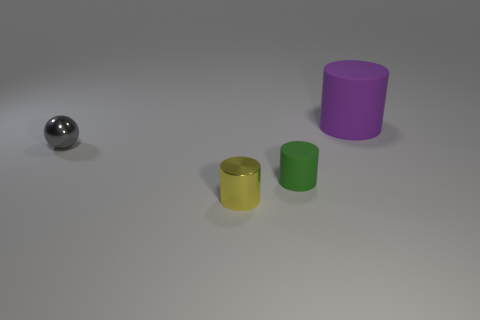Is there any other thing that is the same size as the purple rubber cylinder?
Make the answer very short. No. Do the cylinder behind the sphere and the tiny cylinder that is to the left of the green rubber object have the same material?
Give a very brief answer. No. What number of small yellow cylinders are in front of the tiny green cylinder?
Provide a short and direct response. 1. What number of purple things are tiny shiny things or tiny matte objects?
Provide a short and direct response. 0. There is a cylinder that is the same size as the yellow metallic thing; what is its material?
Offer a terse response. Rubber. What is the shape of the small thing that is both on the right side of the small shiny ball and behind the yellow shiny cylinder?
Ensure brevity in your answer.  Cylinder. There is a shiny ball that is the same size as the yellow shiny cylinder; what color is it?
Make the answer very short. Gray. Do the rubber object in front of the tiny gray sphere and the thing that is on the left side of the yellow shiny thing have the same size?
Offer a very short reply. Yes. There is a metallic object that is to the left of the cylinder in front of the small cylinder that is on the right side of the small yellow object; how big is it?
Ensure brevity in your answer.  Small. There is a metal object that is to the left of the small cylinder in front of the green matte thing; what shape is it?
Offer a terse response. Sphere. 